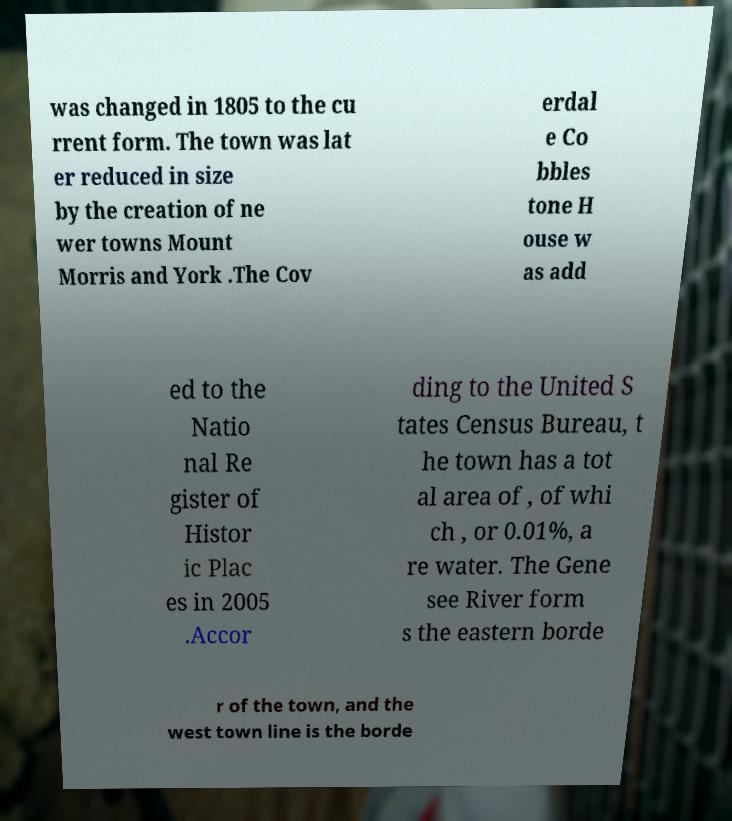There's text embedded in this image that I need extracted. Can you transcribe it verbatim? was changed in 1805 to the cu rrent form. The town was lat er reduced in size by the creation of ne wer towns Mount Morris and York .The Cov erdal e Co bbles tone H ouse w as add ed to the Natio nal Re gister of Histor ic Plac es in 2005 .Accor ding to the United S tates Census Bureau, t he town has a tot al area of , of whi ch , or 0.01%, a re water. The Gene see River form s the eastern borde r of the town, and the west town line is the borde 